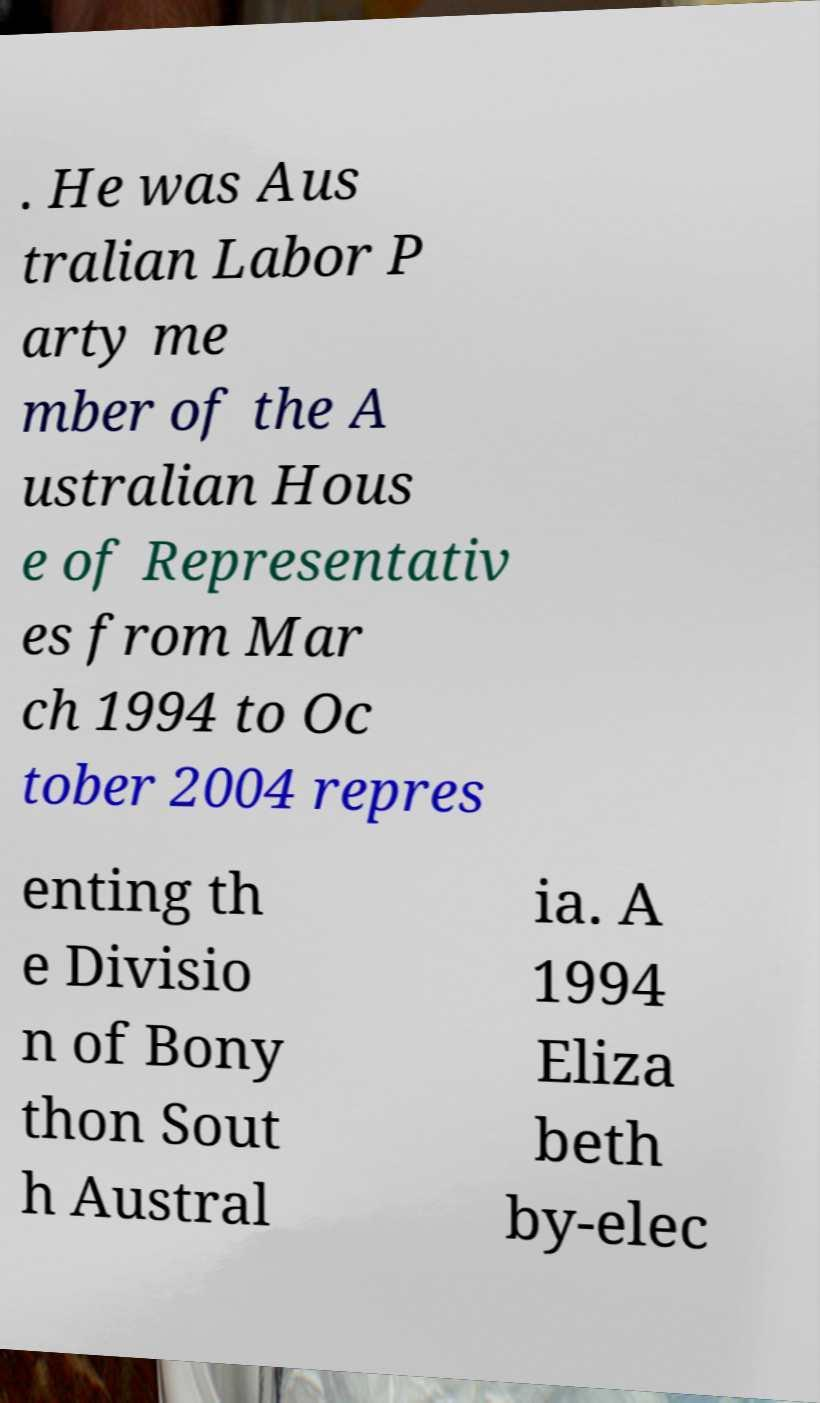Please read and relay the text visible in this image. What does it say? . He was Aus tralian Labor P arty me mber of the A ustralian Hous e of Representativ es from Mar ch 1994 to Oc tober 2004 repres enting th e Divisio n of Bony thon Sout h Austral ia. A 1994 Eliza beth by-elec 